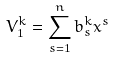Convert formula to latex. <formula><loc_0><loc_0><loc_500><loc_500>V _ { 1 } ^ { k } = \sum _ { s = 1 } ^ { n } b _ { s } ^ { k } x ^ { s }</formula> 